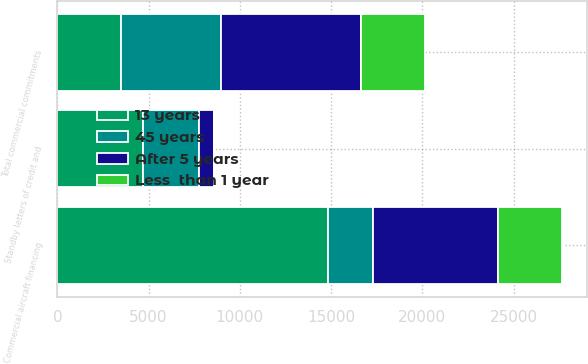Convert chart. <chart><loc_0><loc_0><loc_500><loc_500><stacked_bar_chart><ecel><fcel>Standby letters of credit and<fcel>Commercial aircraft financing<fcel>Total commercial commitments<nl><fcel>13 years<fcel>4701<fcel>14847<fcel>3496<nl><fcel>45 years<fcel>3051<fcel>2432<fcel>5483<nl><fcel>After 5 years<fcel>805<fcel>6874<fcel>7679<nl><fcel>Less  than 1 year<fcel>3<fcel>3493<fcel>3496<nl></chart> 